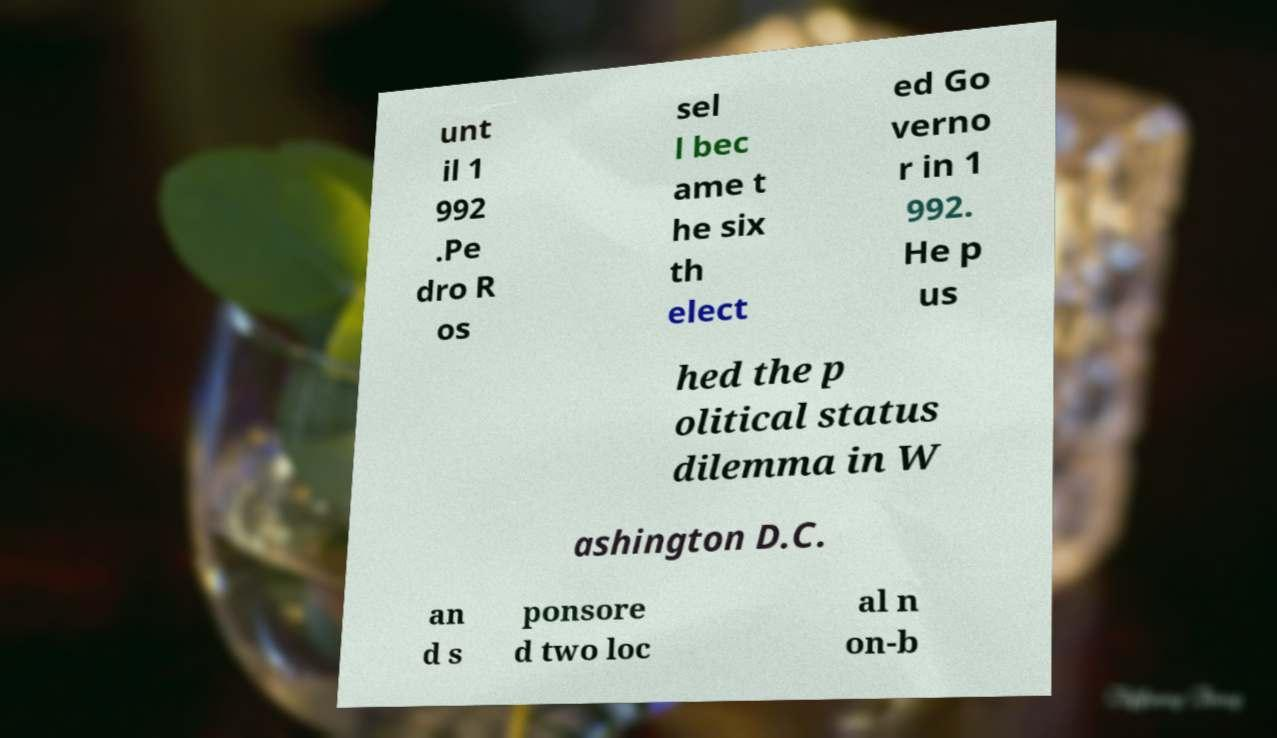Please identify and transcribe the text found in this image. unt il 1 992 .Pe dro R os sel l bec ame t he six th elect ed Go verno r in 1 992. He p us hed the p olitical status dilemma in W ashington D.C. an d s ponsore d two loc al n on-b 